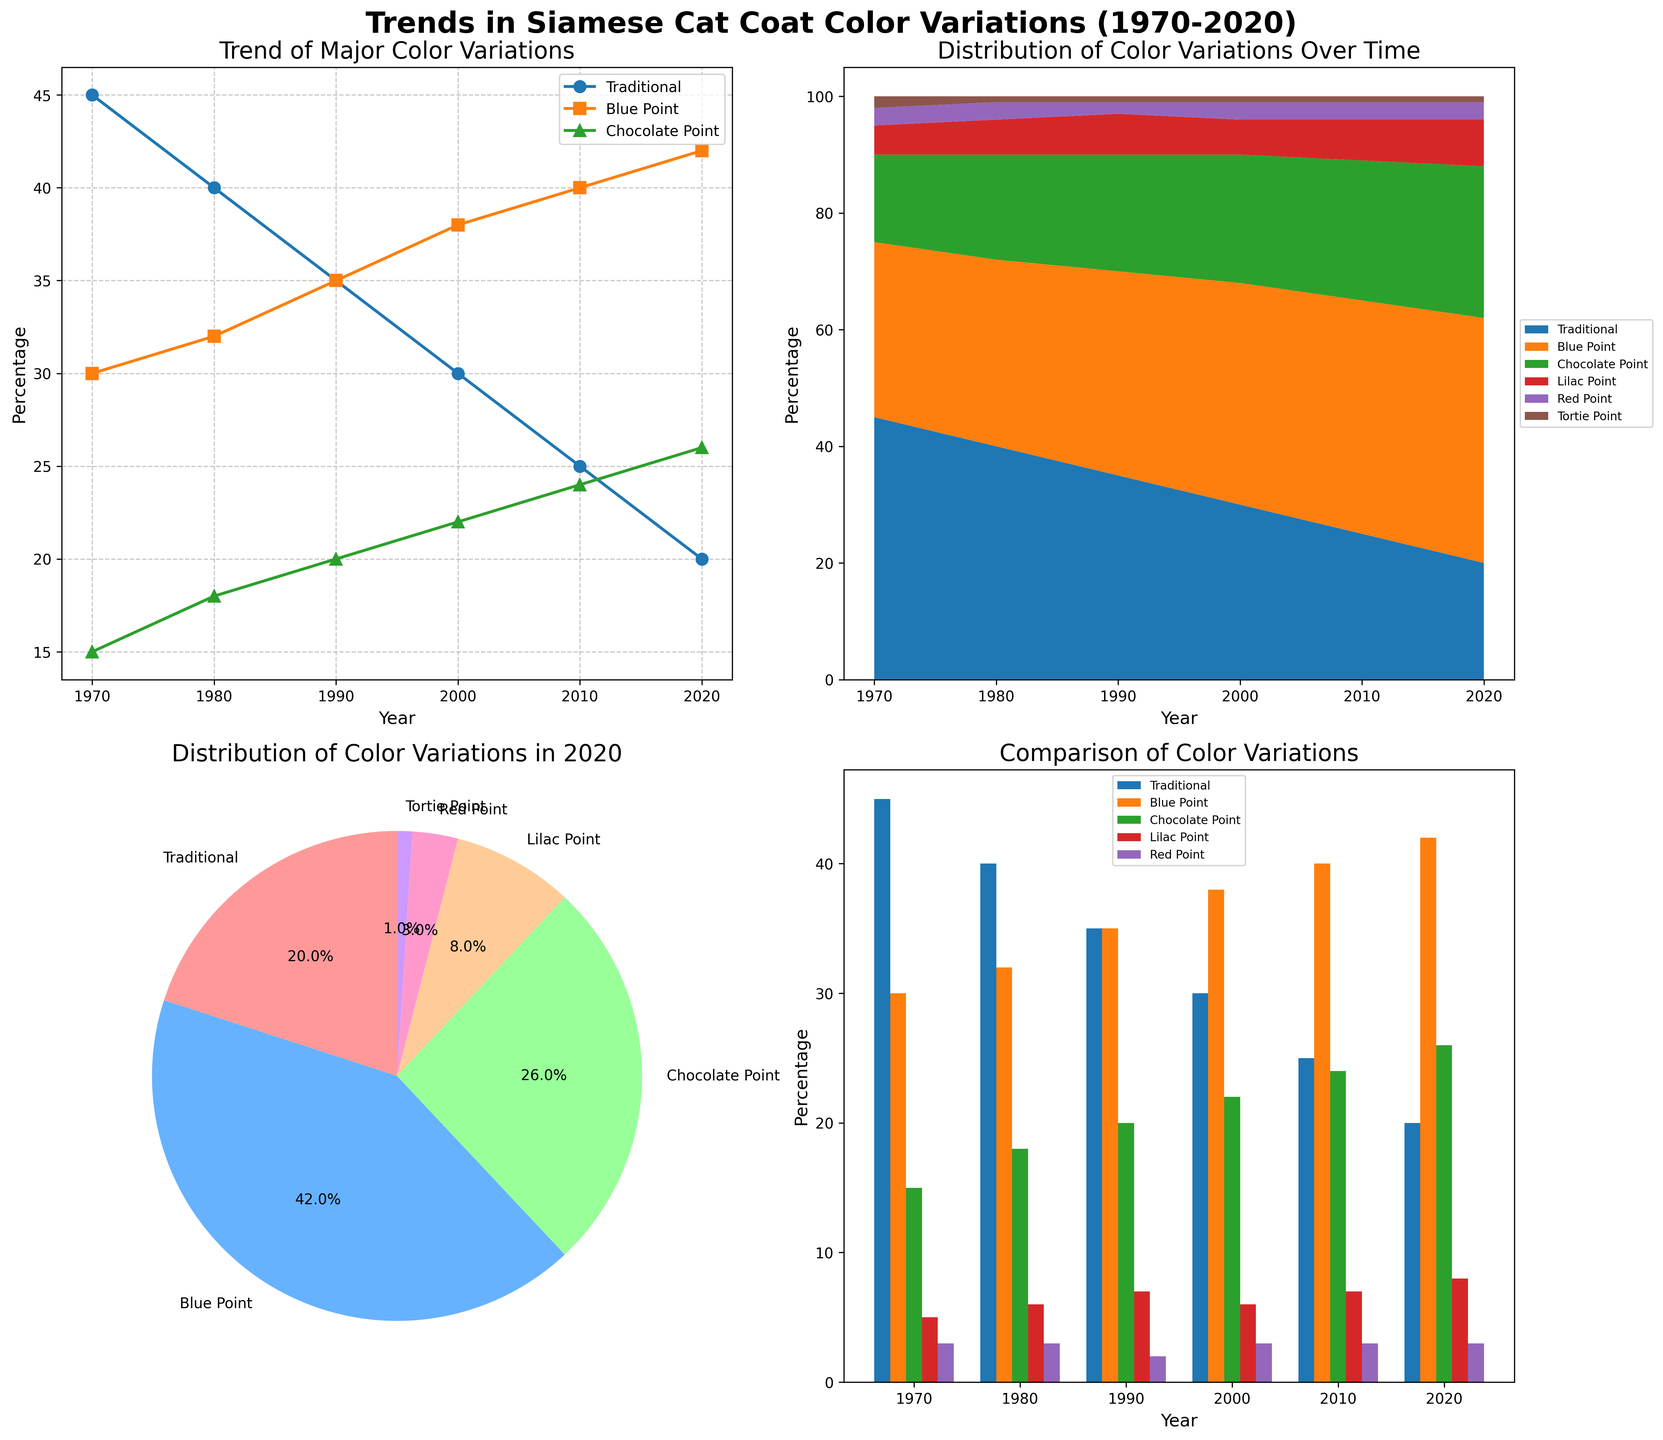What is the title of the entire figure? The title is located above all the subplots and provides an overview of the data being presented. It reads "Trends in Siamese Cat Coat Color Variations (1970-2020)"
Answer: Trends in Siamese Cat Coat Color Variations (1970-2020) Which Siamese cat color variation had the highest percentage in 2020 according to the pie chart? The pie chart in the bottom left subplot visually breaks down the distribution of color variations in 2020. The "Blue Point" section is the largest.
Answer: Blue Point Between which years did the "Traditional" coat color variation show the most significant decrease according to the line plot? To determine this, compare the values on the y-axis for "Traditional" across different years in the top left line plot. The most significant drop happened between 1970 and 2020.
Answer: 1970-2020 Looking at the stacked area plot, which Siamese cat coat color variations maintain a near-constant percentage throughout the years? In the stacked area plot at the top right, the areas representing "Red Point" and "Tortie Point" appear nearly constant over the years.
Answer: Red Point, Tortie Point Which coat color variation showed the greatest increase in percentage between 1970 and 2020 as per the bar chart? By examining the bars for each coat color from 1970 to 2020 in the bottom right bar chart, "Blue Point" shows the most considerable increase in height.
Answer: Blue Point How does the trend of "Chocolate Point" compare with "Lilac Point" from 1970 to 2020 in the line plot? In the line plot at the top left, "Chocolate Point" shows a consistent increase, while "Lilac Point" also increases but at a slower rate. Both trends overall are upward.
Answer: Both increase, "Chocolate Point" more consistently In the stacked area plot, what can you infer about the total percentage of non-traditional coat colors over the years? The stacked area plot shows that the total percentage of non-traditional coat colors (all other colors combined) increased over the years as the "Traditional" section decreased.
Answer: Increased Which year had the smallest percentage of "Traditional" coat color as displayed in the bar chart? In the bottom right bar chart, the shortest bar representing "Traditional" is in 2020.
Answer: 2020 What visual element in the pie chart helps quickly identify the percentage distribution of each coat color variation? The pie chart uses different colors and labels for each section, with percentages noted on each, helping to quickly identify each distribution.
Answer: Colors and labels with percentages Analyzing the entire figure, what general trend can be observed for the popularity of non-traditional coat colors over 50 years? Across all subplots, it is evident that non-traditional coat colors have become more popular, increasing in percentage compared to the traditional color.
Answer: Increase in popularity 